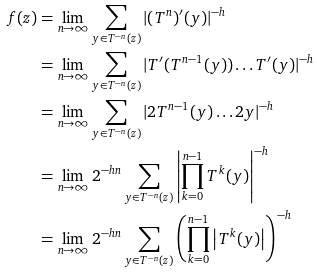Convert formula to latex. <formula><loc_0><loc_0><loc_500><loc_500>f ( z ) & = \lim _ { n \to \infty } \sum _ { y \in T ^ { - n } ( z ) } | ( T ^ { n } ) ^ { \prime } ( y ) | ^ { - h } \\ & = \lim _ { n \to \infty } \sum _ { y \in T ^ { - n } ( z ) } | T ^ { \prime } ( T ^ { n - 1 } ( y ) ) \dots T ^ { \prime } ( y ) | ^ { - h } \\ & = \lim _ { n \to \infty } \sum _ { y \in T ^ { - n } ( z ) } | 2 T ^ { n - 1 } ( y ) \dots 2 y | ^ { - h } \\ & = \lim _ { n \to \infty } 2 ^ { - h n } \sum _ { y \in T ^ { - n } ( z ) } \left | \prod _ { k = 0 } ^ { n - 1 } T ^ { k } ( y ) \right | ^ { - h } \\ & = \lim _ { n \to \infty } 2 ^ { - h n } \sum _ { y \in T ^ { - n } ( z ) } \left ( \prod _ { k = 0 } ^ { n - 1 } \left | T ^ { k } ( y ) \right | \right ) ^ { - h }</formula> 